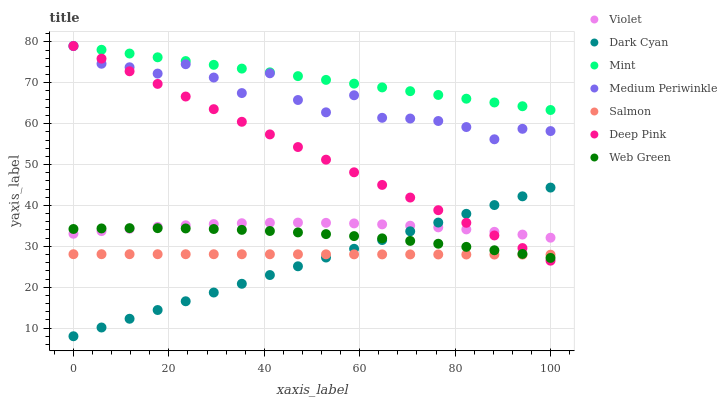Does Dark Cyan have the minimum area under the curve?
Answer yes or no. Yes. Does Mint have the maximum area under the curve?
Answer yes or no. Yes. Does Salmon have the minimum area under the curve?
Answer yes or no. No. Does Salmon have the maximum area under the curve?
Answer yes or no. No. Is Dark Cyan the smoothest?
Answer yes or no. Yes. Is Medium Periwinkle the roughest?
Answer yes or no. Yes. Is Salmon the smoothest?
Answer yes or no. No. Is Salmon the roughest?
Answer yes or no. No. Does Dark Cyan have the lowest value?
Answer yes or no. Yes. Does Salmon have the lowest value?
Answer yes or no. No. Does Mint have the highest value?
Answer yes or no. Yes. Does Salmon have the highest value?
Answer yes or no. No. Is Salmon less than Medium Periwinkle?
Answer yes or no. Yes. Is Mint greater than Web Green?
Answer yes or no. Yes. Does Salmon intersect Web Green?
Answer yes or no. Yes. Is Salmon less than Web Green?
Answer yes or no. No. Is Salmon greater than Web Green?
Answer yes or no. No. Does Salmon intersect Medium Periwinkle?
Answer yes or no. No. 